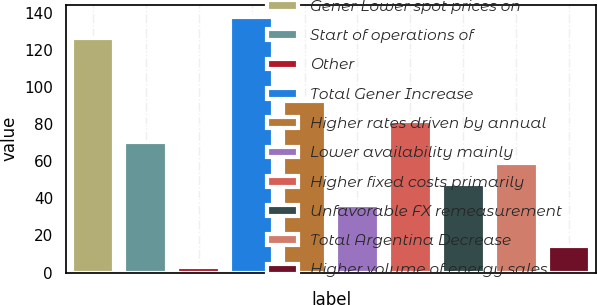Convert chart. <chart><loc_0><loc_0><loc_500><loc_500><bar_chart><fcel>Gener Lower spot prices on<fcel>Start of operations of<fcel>Other<fcel>Total Gener Increase<fcel>Higher rates driven by annual<fcel>Lower availability mainly<fcel>Higher fixed costs primarily<fcel>Unfavorable FX remeasurement<fcel>Total Argentina Decrease<fcel>Higher volume of energy sales<nl><fcel>126.2<fcel>70.2<fcel>3<fcel>137.4<fcel>92.6<fcel>36.6<fcel>81.4<fcel>47.8<fcel>59<fcel>14.2<nl></chart> 